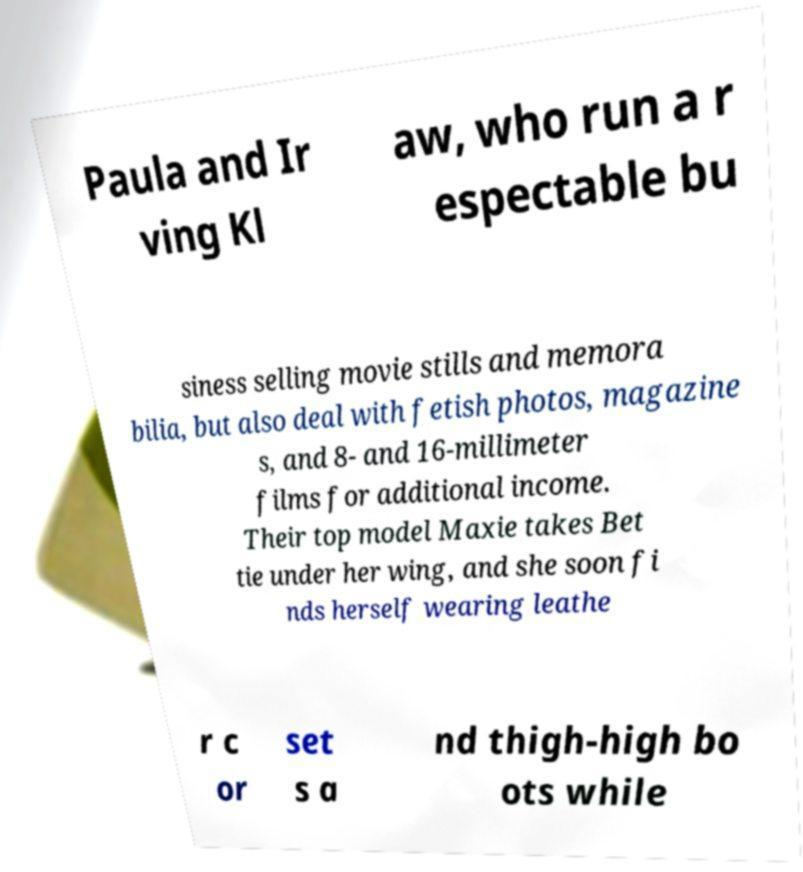Please read and relay the text visible in this image. What does it say? Paula and Ir ving Kl aw, who run a r espectable bu siness selling movie stills and memora bilia, but also deal with fetish photos, magazine s, and 8- and 16-millimeter films for additional income. Their top model Maxie takes Bet tie under her wing, and she soon fi nds herself wearing leathe r c or set s a nd thigh-high bo ots while 